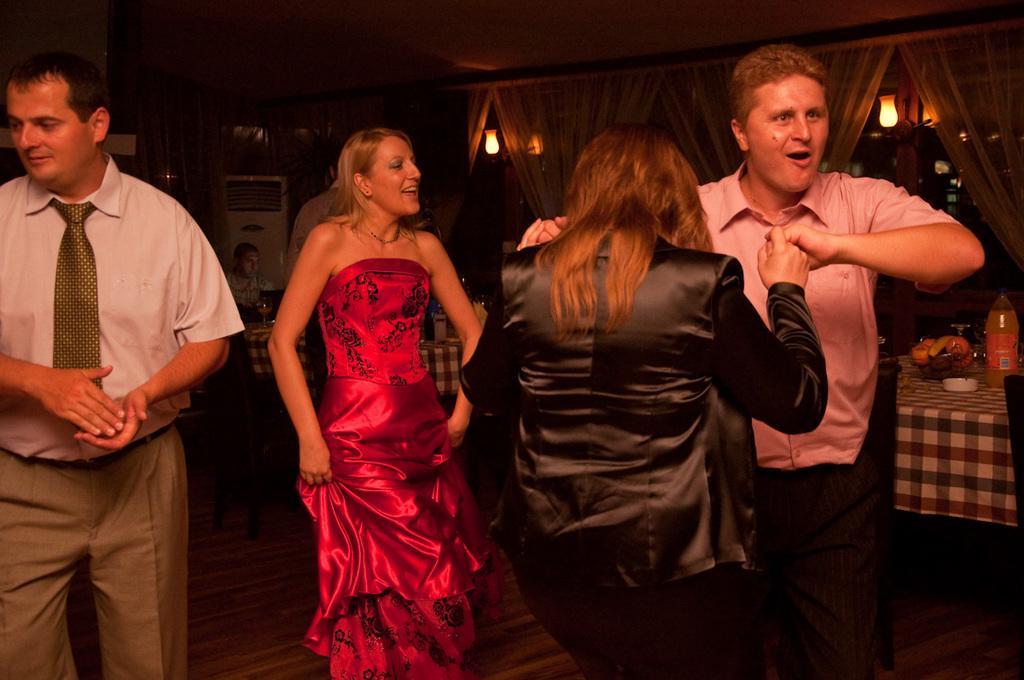Could you give a brief overview of what you see in this image? In this image there are few people dancing on the floor, behind them there are tables and chairs. On the table there are food items, bottles and a few other objects placed on it and a person is sitting on the chair, beside him there are few objects. In the background there are curtains and lamps are hanging on the wall. 